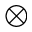<formula> <loc_0><loc_0><loc_500><loc_500>\otimes</formula> 